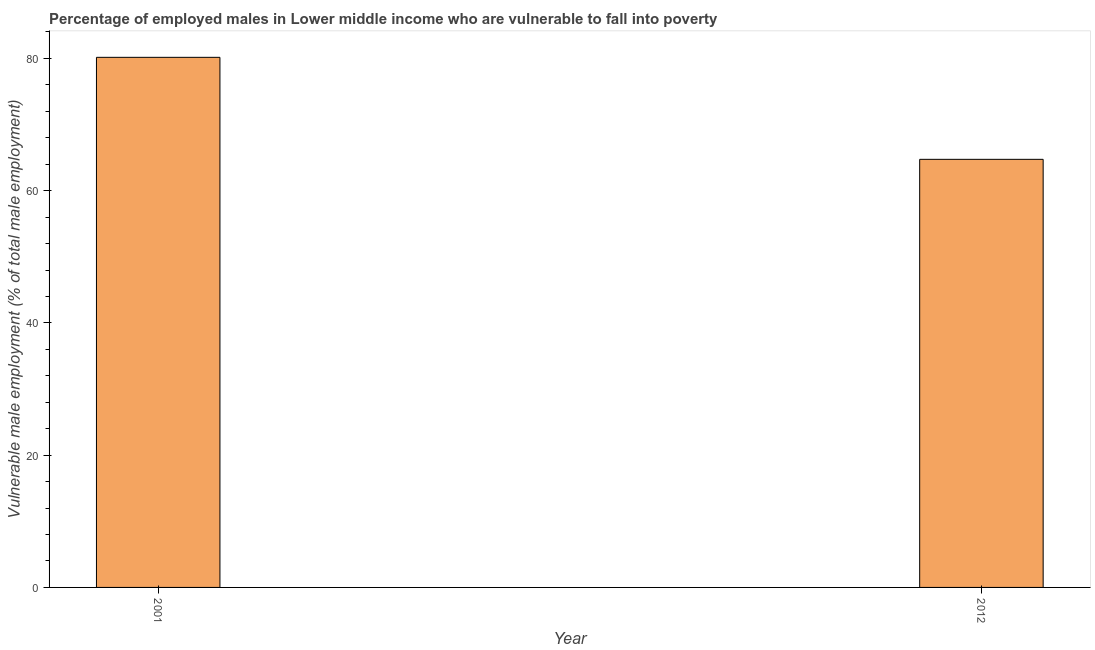Does the graph contain any zero values?
Give a very brief answer. No. What is the title of the graph?
Provide a succinct answer. Percentage of employed males in Lower middle income who are vulnerable to fall into poverty. What is the label or title of the Y-axis?
Your answer should be compact. Vulnerable male employment (% of total male employment). What is the percentage of employed males who are vulnerable to fall into poverty in 2001?
Make the answer very short. 80.16. Across all years, what is the maximum percentage of employed males who are vulnerable to fall into poverty?
Provide a succinct answer. 80.16. Across all years, what is the minimum percentage of employed males who are vulnerable to fall into poverty?
Your answer should be very brief. 64.74. What is the sum of the percentage of employed males who are vulnerable to fall into poverty?
Provide a short and direct response. 144.9. What is the difference between the percentage of employed males who are vulnerable to fall into poverty in 2001 and 2012?
Your response must be concise. 15.43. What is the average percentage of employed males who are vulnerable to fall into poverty per year?
Provide a short and direct response. 72.45. What is the median percentage of employed males who are vulnerable to fall into poverty?
Keep it short and to the point. 72.45. Do a majority of the years between 2001 and 2012 (inclusive) have percentage of employed males who are vulnerable to fall into poverty greater than 40 %?
Your response must be concise. Yes. What is the ratio of the percentage of employed males who are vulnerable to fall into poverty in 2001 to that in 2012?
Offer a very short reply. 1.24. In how many years, is the percentage of employed males who are vulnerable to fall into poverty greater than the average percentage of employed males who are vulnerable to fall into poverty taken over all years?
Your answer should be compact. 1. Are all the bars in the graph horizontal?
Offer a terse response. No. What is the difference between two consecutive major ticks on the Y-axis?
Provide a short and direct response. 20. What is the Vulnerable male employment (% of total male employment) in 2001?
Give a very brief answer. 80.16. What is the Vulnerable male employment (% of total male employment) of 2012?
Ensure brevity in your answer.  64.74. What is the difference between the Vulnerable male employment (% of total male employment) in 2001 and 2012?
Your answer should be very brief. 15.42. What is the ratio of the Vulnerable male employment (% of total male employment) in 2001 to that in 2012?
Provide a short and direct response. 1.24. 